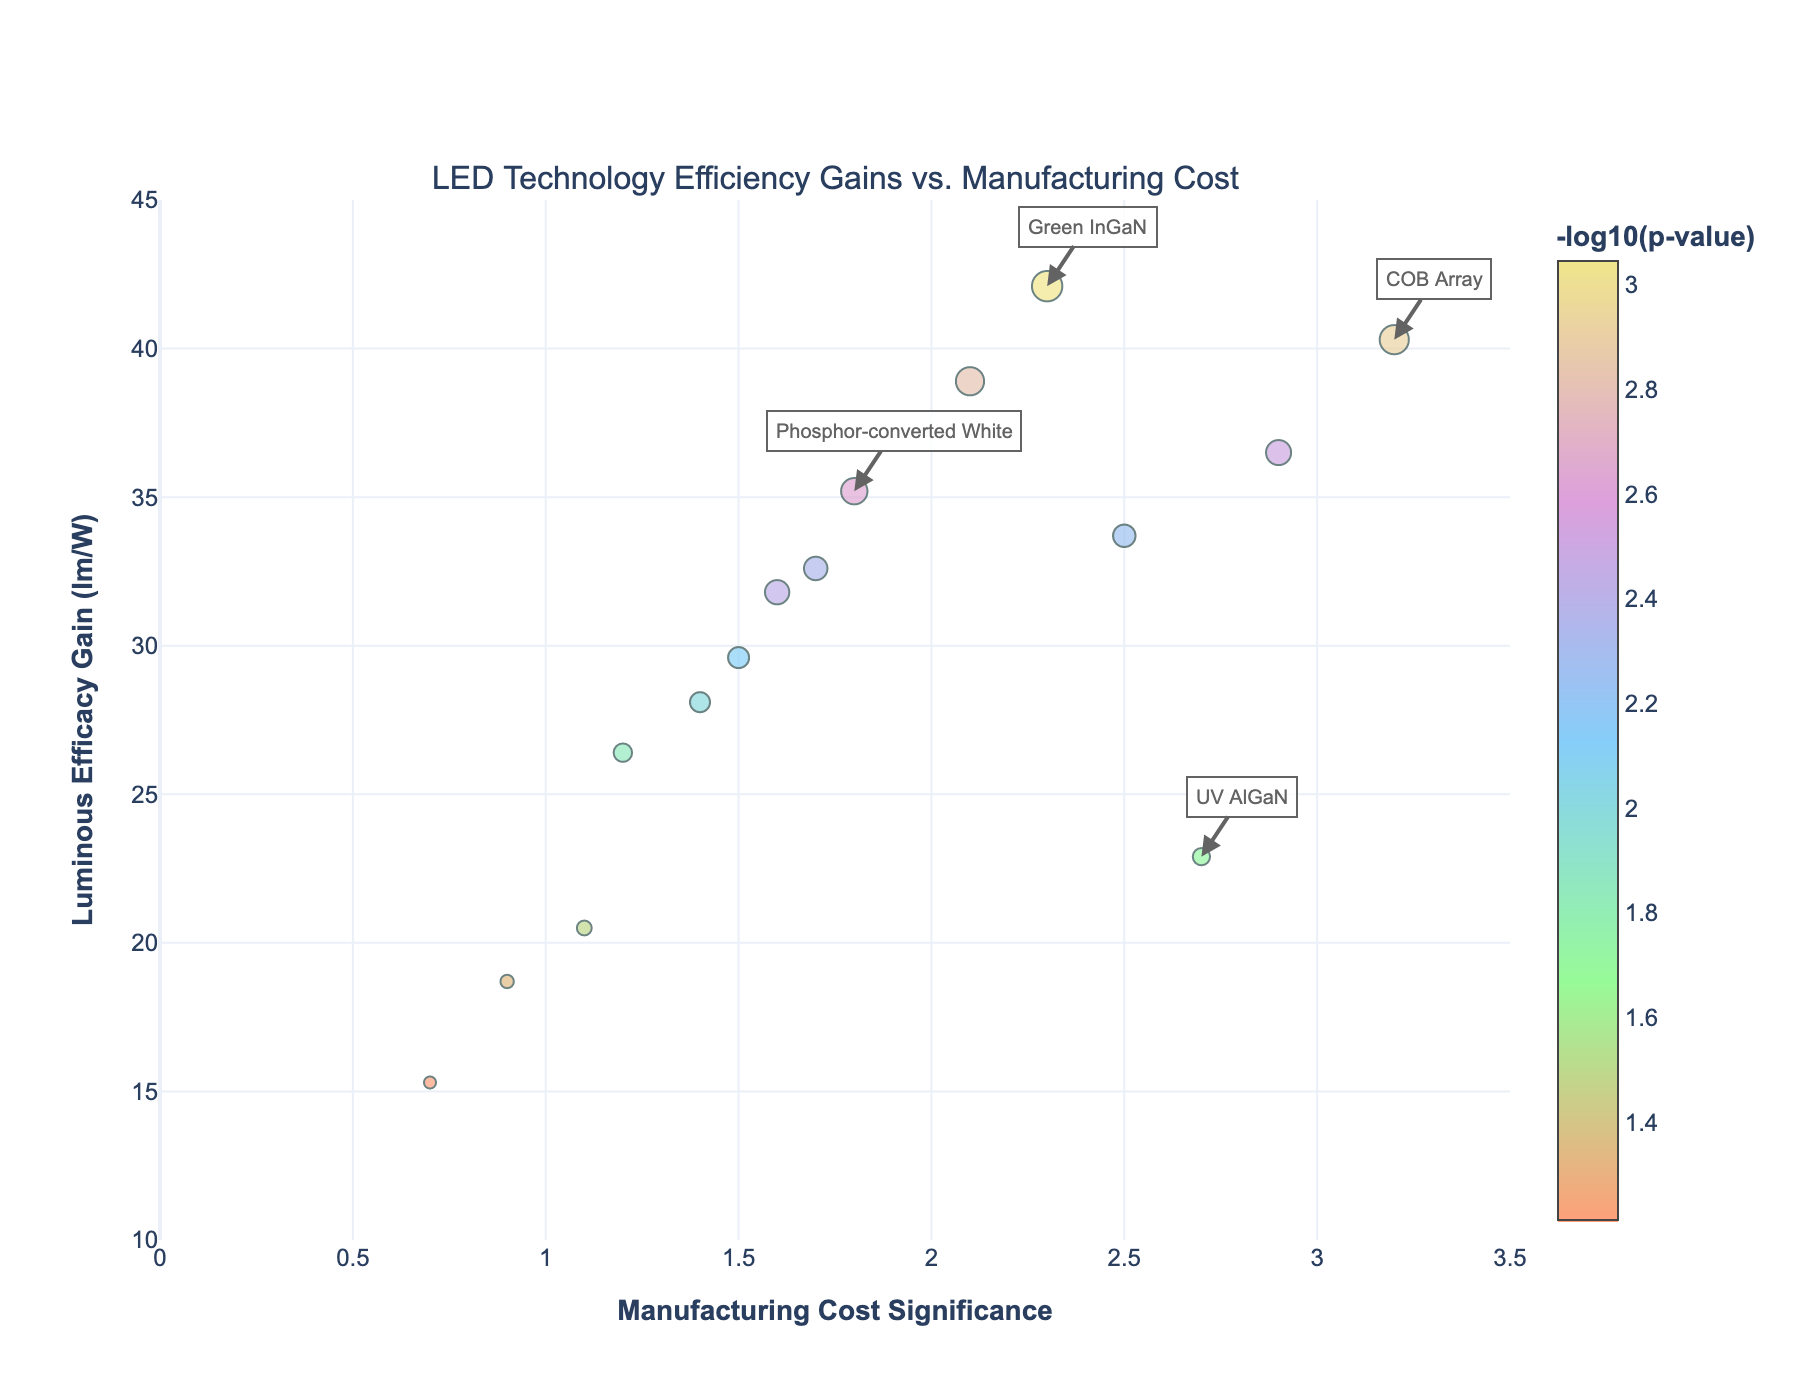What's the title of the plot? The plot's title is usually given at the top of the figure. This helps the viewer understand the main subject of the plot.
Answer: LED Technology Efficiency Gains vs. Manufacturing Cost What are the units for the y-axis? The y-axis title is "Luminous Efficacy Gain (lm/W)," which means the units are lumens per watt (lm/W). This measures how efficiently an LED converts power into light.
Answer: lumens per watt How many LED technologies have a significantly small p-value (less than 0.01)? By examining the color bar and the size of the markers, we can identify points with a high -log10(p-value) since smaller p-values correspond to higher -log10(p-value). Counting these points on the plot gives us the answer.
Answer: 8 Which LED type shows the highest luminous efficacy gain? By looking at the topmost point on the y-axis, we can determine the LED type with the highest luminous efficacy gain.
Answer: Green InGaN Which LED type has the highest manufacturing cost significance? By locating the furthest point to the right on the x-axis, we find the LED type with the highest manufacturing cost significance.
Answer: COB Array What is the approximate luminous efficacy gain of the UV AlGaN LED? Find the UV AlGaN LED on the plot and look at its y-coordinate to determine the efficacy gain.
Answer: 22.9 lm/W Which LED technologies are annotated in the plot? Looking for labels and annotations on the plot helps us identify specific LED types of interest.
Answer: Green InGaN, COB Array, Phosphor-converted White, UV AlGaN Is there a general trend between manufacturing cost significance and luminous efficacy gain? Observing the distribution of points on the plot, we can look for patterns or trends across the x and y axes.
Answer: No clear trend What does a large marker size indicate on this plot? The legend or color bar tells us that larger markers correspond to higher -log10(p-value), indicating more significant results in terms of statistical significance.
Answer: More significant p-value Which two LED types are the closest in terms of luminous efficacy gain but have different manufacturing cost significance values? Finding the closest points vertically allows us to identify which LEDs have similar efficacy gains while checking how they differ in manufacturing cost significance.
Answer: Warm White Hybrid and Phosphor-converted White 